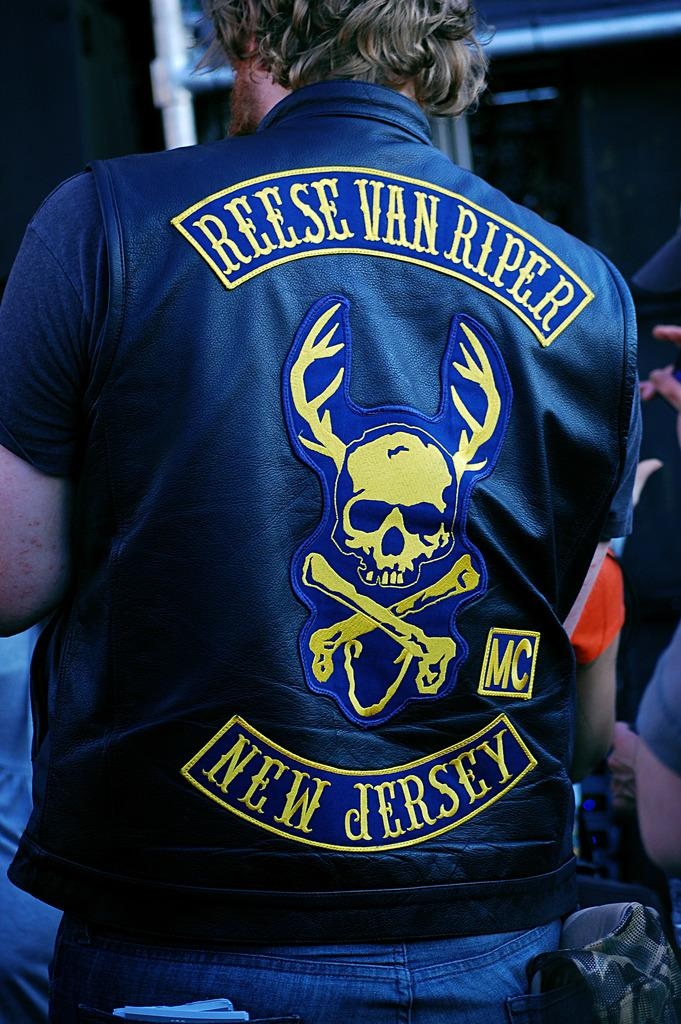<image>
Provide a brief description of the given image. A man wearing a biker jacket from a New Jersey motorcycle club. 